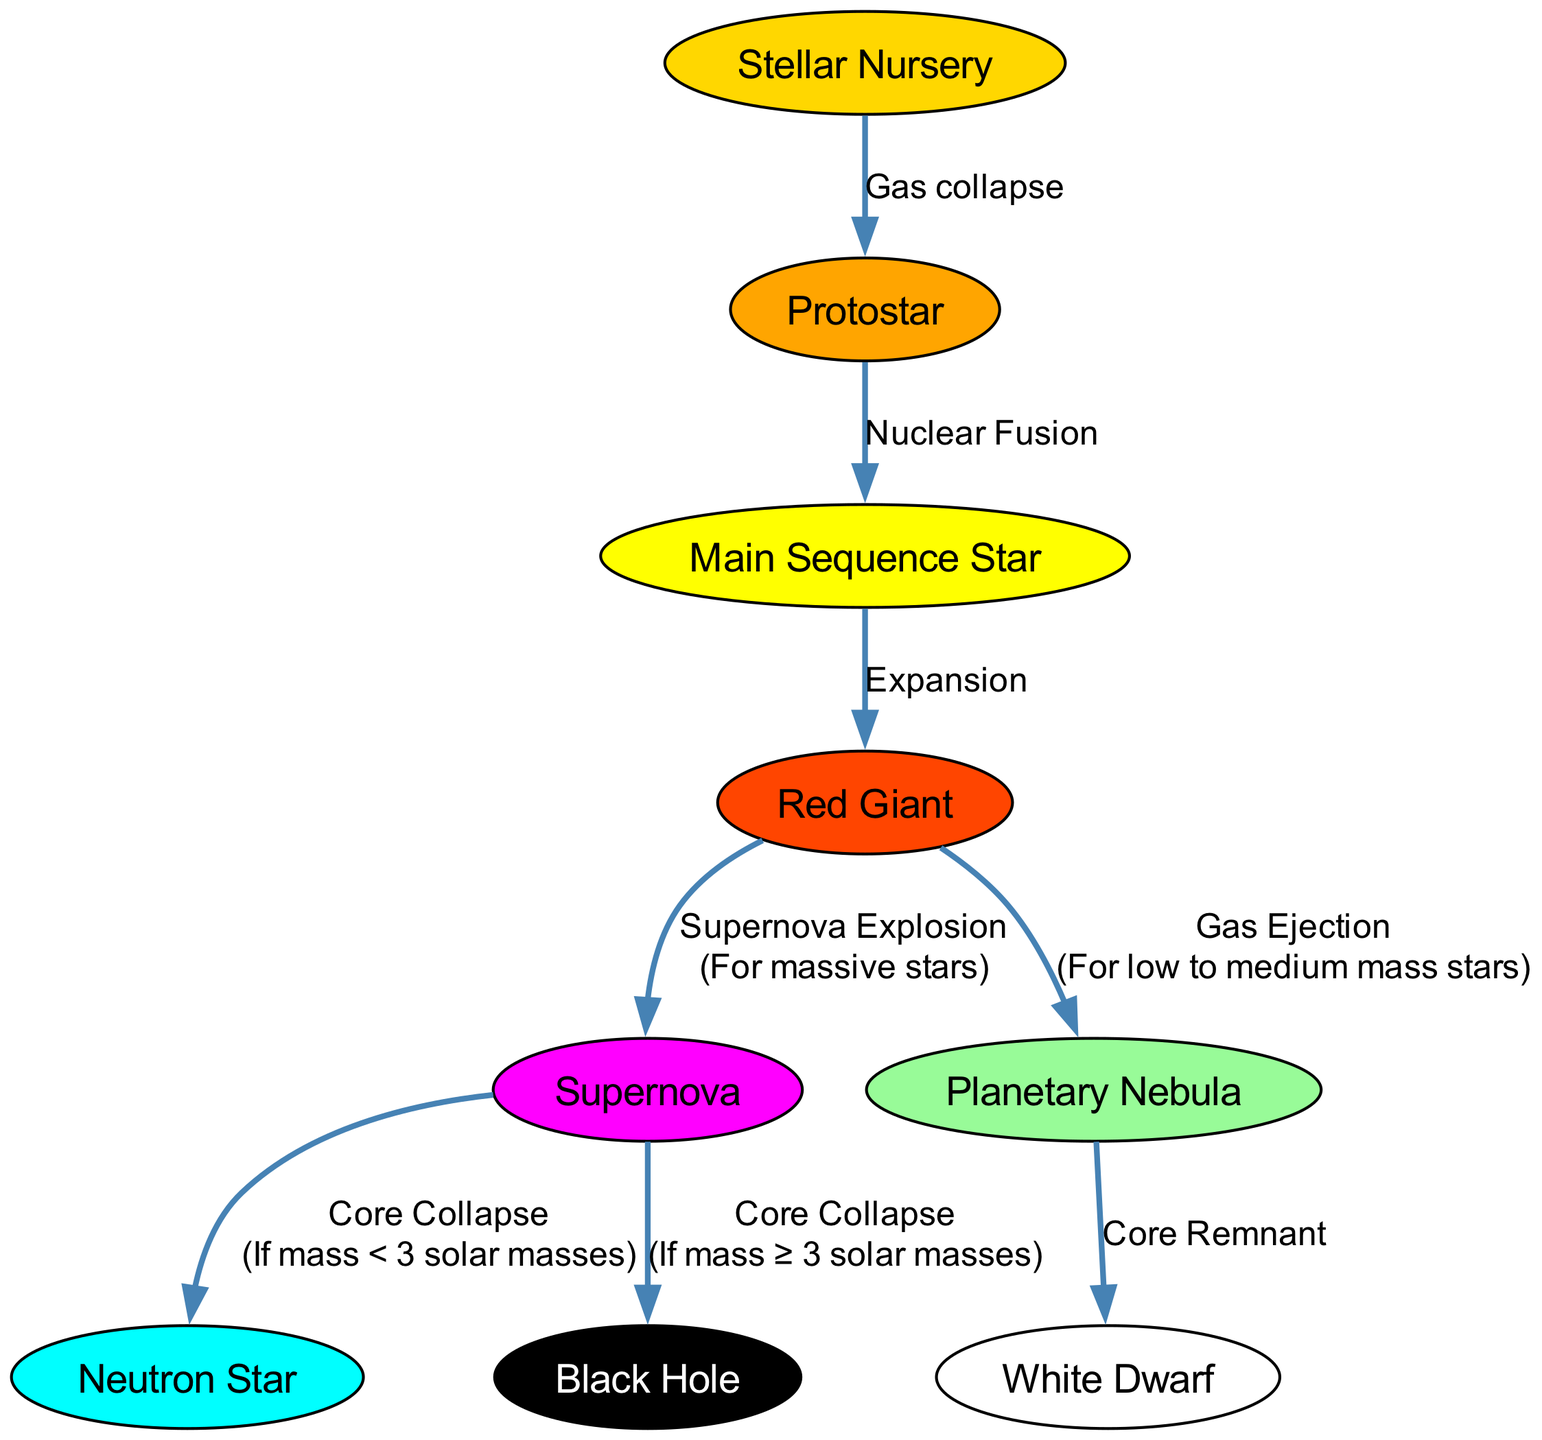What is the first stage of star formation? The diagram indicates that the first stage of star formation is a "Stellar Nursery," where dense regions of gas and dust facilitate the birth of stars.
Answer: Stellar Nursery How many nodes are present in the lifecycle of stars diagram? By counting the nodes listed in the data, we find there are nine distinct nodes representing different stages and objects in the lifecycle of stars.
Answer: 9 What is formed after the Protostar stage? The diagram shows that after the Protostar stage, the star enters the Main Sequence Star phase due to nuclear fusion starting to occur in its core.
Answer: Main Sequence Star What occurs when a Red Giant star reaches its end state? The diagram illustrates two possible outcomes for a Red Giant: it can either eject gas to form a Planetary Nebula, leading to a White Dwarf, or undergo a Supernova explosion if it is a massive star.
Answer: Planetary Nebula or Supernova What type of remnant is created from a Supernova explosion with a mass less than 3 solar masses? According to the diagram, if a Supernova explosion occurs with a mass of less than 3 solar masses, the remnant formed is a Neutron Star.
Answer: Neutron Star What relationship exists between the Red Giant and Supernova? The diagram indicates that the Red Giant can lead to a Supernova explosion, but this happens specifically for massive stars, demonstrating a crucial transition in its lifecycle.
Answer: Transition to Supernova What is the endpoint for a massive star after a Supernova explosion? The diagram states that for a massive star (mass greater than or equal to 3 solar masses), the endpoint following a Supernova explosion is a Black Hole.
Answer: Black Hole What is the condition for forming a White Dwarf? The diagram specifies that a White Dwarf is formed as a remnant core after the Planetary Nebula stage, which occurs for low to medium mass stars. The condition is tied to the mass of the initial star.
Answer: Low to Medium Mass Stars 